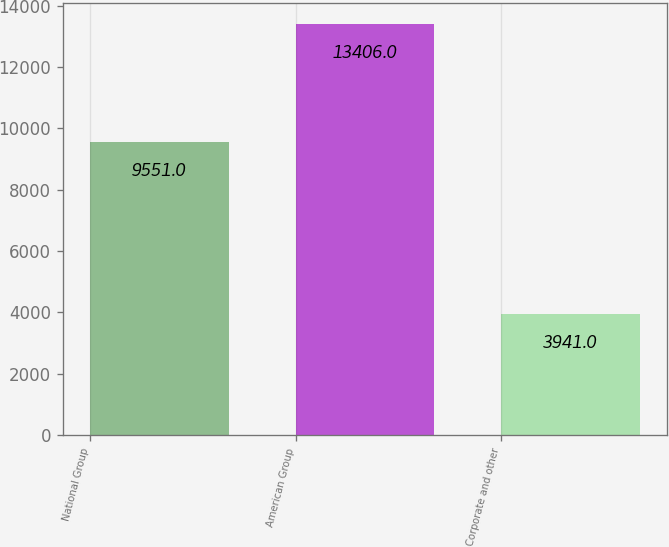Convert chart to OTSL. <chart><loc_0><loc_0><loc_500><loc_500><bar_chart><fcel>National Group<fcel>American Group<fcel>Corporate and other<nl><fcel>9551<fcel>13406<fcel>3941<nl></chart> 